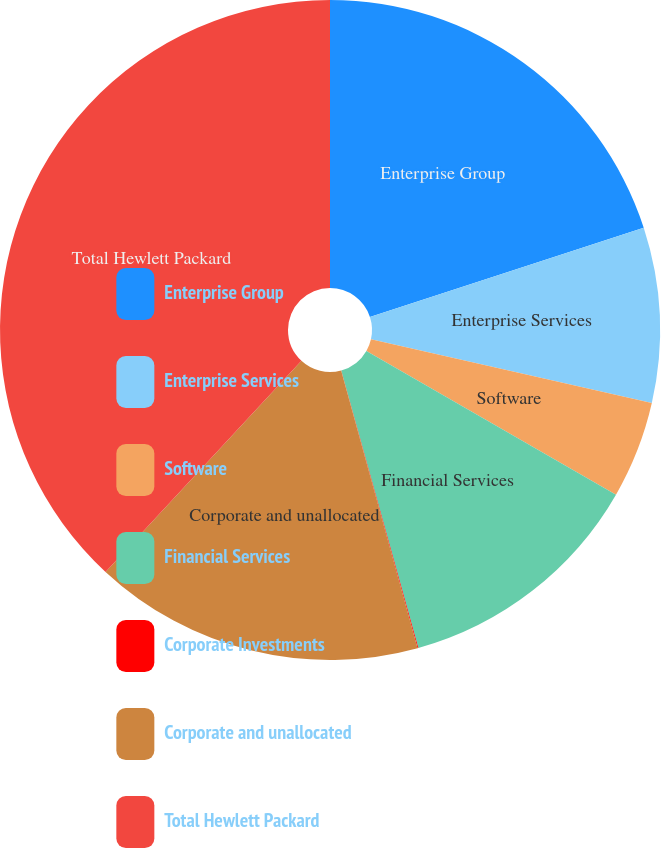<chart> <loc_0><loc_0><loc_500><loc_500><pie_chart><fcel>Enterprise Group<fcel>Enterprise Services<fcel>Software<fcel>Financial Services<fcel>Corporate Investments<fcel>Corporate and unallocated<fcel>Total Hewlett Packard<nl><fcel>19.98%<fcel>8.57%<fcel>4.76%<fcel>12.37%<fcel>0.04%<fcel>16.18%<fcel>38.09%<nl></chart> 